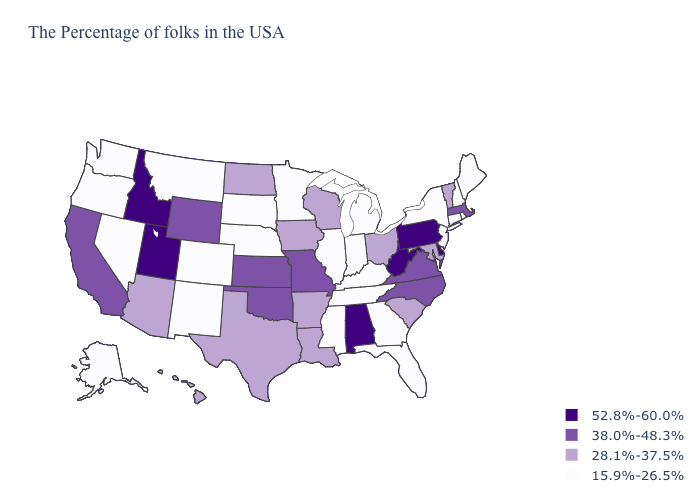Name the states that have a value in the range 38.0%-48.3%?
Be succinct. Massachusetts, Virginia, North Carolina, Missouri, Kansas, Oklahoma, Wyoming, California. Name the states that have a value in the range 15.9%-26.5%?
Short answer required. Maine, Rhode Island, New Hampshire, Connecticut, New York, New Jersey, Florida, Georgia, Michigan, Kentucky, Indiana, Tennessee, Illinois, Mississippi, Minnesota, Nebraska, South Dakota, Colorado, New Mexico, Montana, Nevada, Washington, Oregon, Alaska. Name the states that have a value in the range 38.0%-48.3%?
Answer briefly. Massachusetts, Virginia, North Carolina, Missouri, Kansas, Oklahoma, Wyoming, California. Among the states that border Kentucky , does West Virginia have the highest value?
Answer briefly. Yes. Does the first symbol in the legend represent the smallest category?
Keep it brief. No. Which states hav the highest value in the Northeast?
Concise answer only. Pennsylvania. Name the states that have a value in the range 38.0%-48.3%?
Keep it brief. Massachusetts, Virginia, North Carolina, Missouri, Kansas, Oklahoma, Wyoming, California. What is the lowest value in states that border Kansas?
Give a very brief answer. 15.9%-26.5%. Among the states that border Tennessee , does Missouri have the lowest value?
Short answer required. No. What is the value of North Dakota?
Answer briefly. 28.1%-37.5%. How many symbols are there in the legend?
Give a very brief answer. 4. Among the states that border Vermont , which have the lowest value?
Keep it brief. New Hampshire, New York. Name the states that have a value in the range 38.0%-48.3%?
Short answer required. Massachusetts, Virginia, North Carolina, Missouri, Kansas, Oklahoma, Wyoming, California. Among the states that border Illinois , does Missouri have the lowest value?
Keep it brief. No. Does South Carolina have the highest value in the USA?
Answer briefly. No. 